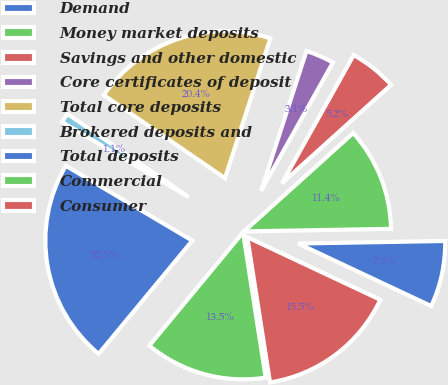<chart> <loc_0><loc_0><loc_500><loc_500><pie_chart><fcel>Demand<fcel>Money market deposits<fcel>Savings and other domestic<fcel>Core certificates of deposit<fcel>Total core deposits<fcel>Brokered deposits and<fcel>Total deposits<fcel>Commercial<fcel>Consumer<nl><fcel>7.27%<fcel>11.4%<fcel>5.2%<fcel>3.13%<fcel>20.43%<fcel>1.06%<fcel>22.5%<fcel>13.47%<fcel>15.54%<nl></chart> 